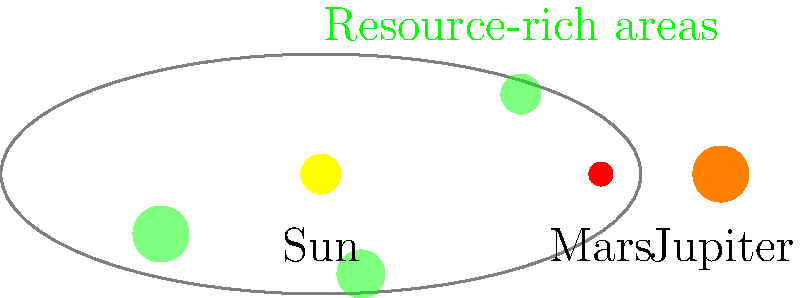In the context of space mining, which ethical concern arises from the highlighted resource-rich areas in the asteroid belt, and how might it relate to existing patterns of global inequality? To answer this question, let's consider the following steps:

1. Observe the diagram: The asteroid belt is shown between Mars and Jupiter, with three highlighted green areas representing resource-rich regions.

2. Understand space mining: Space mining involves extracting valuable resources from asteroids, which could include rare metals, water, and other materials useful for space exploration and Earth-based industries.

3. Identify the ethical concern: The primary ethical issue here is the potential for exploitation and unequal distribution of space resources.

4. Analyze in the context of global inequality:
   a) Current global economic system: Dominated by powerful nations and corporations.
   b) Space mining capabilities: Likely to be developed first by wealthy nations or private companies.
   c) Resource control: Those who can access these resources first may gain disproportionate control and profit.

5. Draw parallels to terrestrial resource exploitation:
   a) Historical colonialism: Extraction of resources from less powerful regions.
   b) Modern economic imperialism: Multinational corporations exploiting resources in developing countries.

6. Consider the implications:
   a) Widening wealth gap: Space resources could further concentrate wealth in the hands of the already powerful.
   b) Technological divide: Nations without space capabilities might be left behind.
   c) Environmental concerns: Potential for reckless exploitation without regard for cosmic ecosystems or long-term sustainability.

7. Relate to socialist perspective:
   a) Critique of free market approach to space resources.
   b) Argument for collective ownership or equitable distribution of space resources.
   c) Need for international regulations to prevent exploitation and ensure fair access.

The ethical concern, therefore, is that space mining could reproduce and amplify existing patterns of global inequality, leading to a new form of cosmic colonialism or imperialism.
Answer: Space mining could perpetuate and exacerbate global inequality through unequal access and exploitation of cosmic resources. 